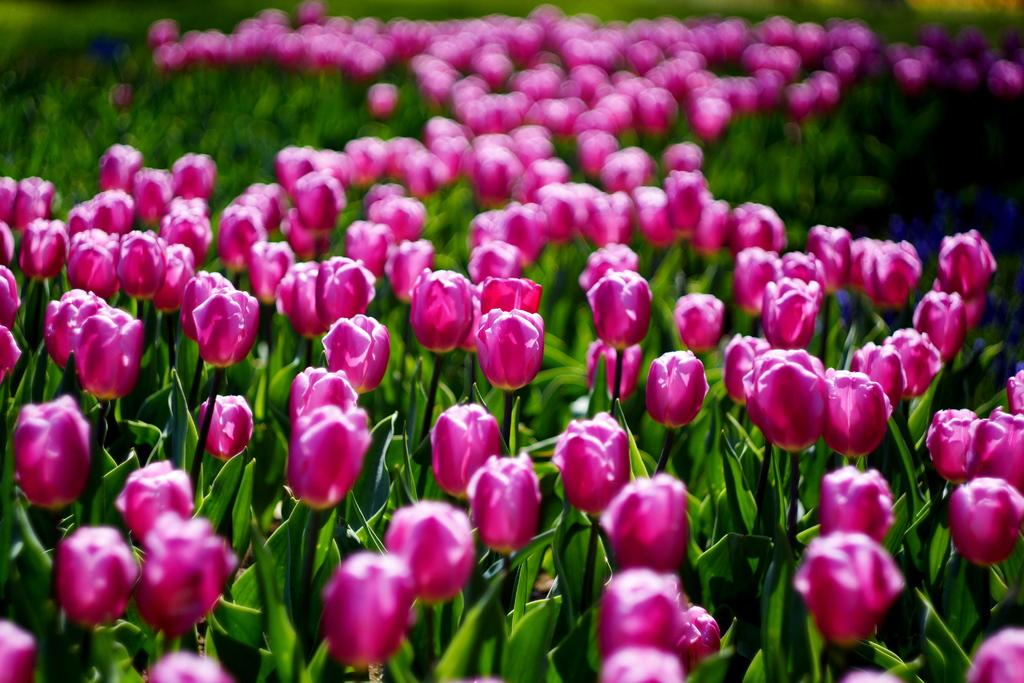What type of living organisms are present in the image? There are plants in the image. What specific parts of the plants can be seen? The plants have leaves and flowers. What unit of measurement is used to describe the size of the page in the image? There is no page present in the image, so it is not possible to determine a unit of measurement for its size. 